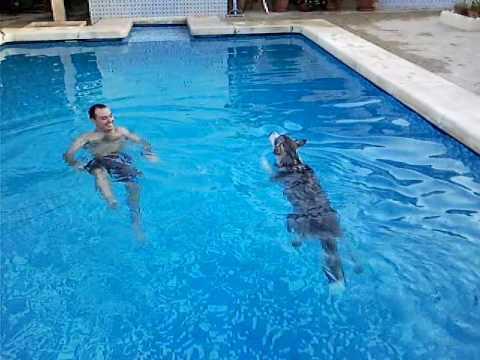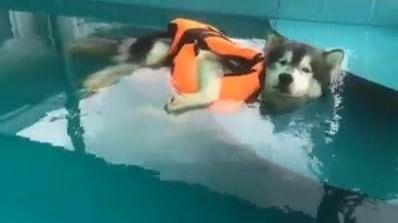The first image is the image on the left, the second image is the image on the right. For the images displayed, is the sentence "In at least one image there is a husky swimming in a pool with a man only wearing shorts." factually correct? Answer yes or no. Yes. The first image is the image on the left, the second image is the image on the right. For the images displayed, is the sentence "In one image, a dog is alone in shallow pool water, but in the second image, a dog is with a man in deeper water." factually correct? Answer yes or no. Yes. 